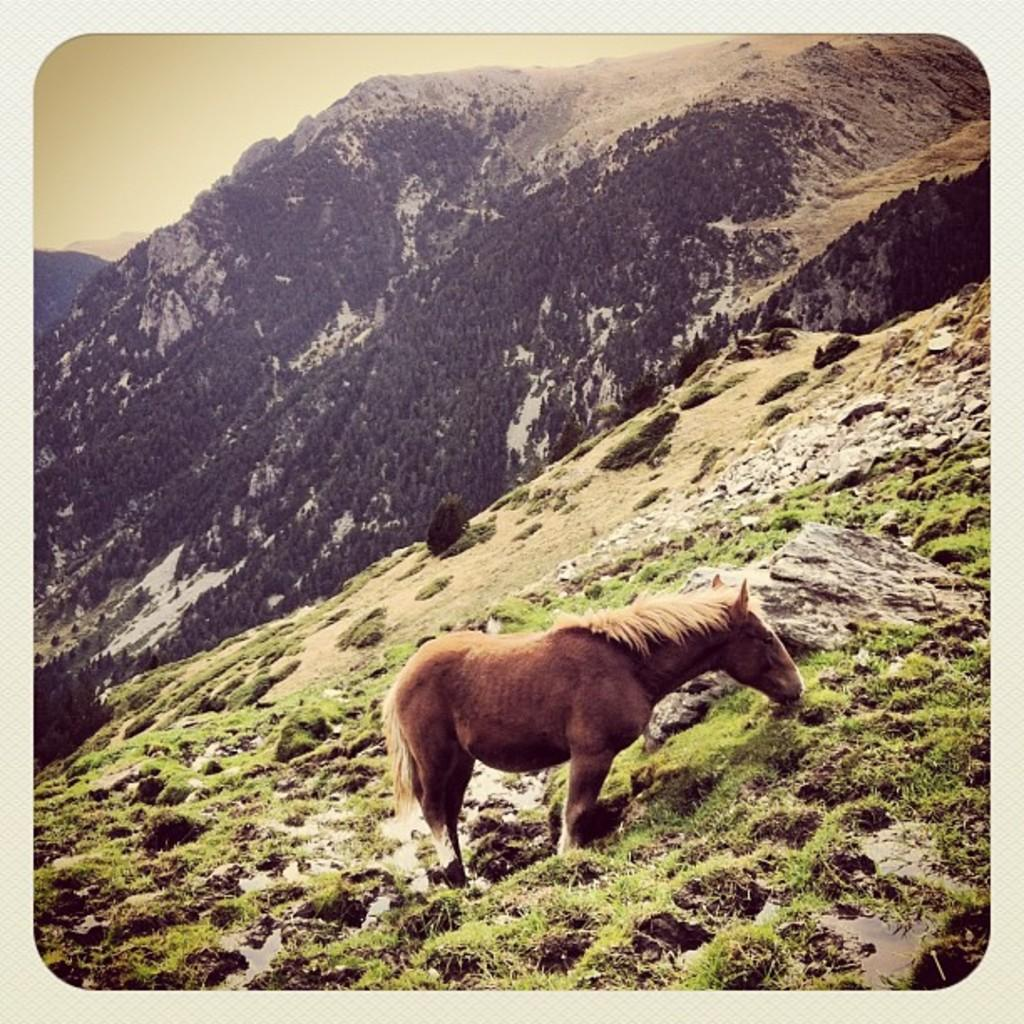What animal is present in the image? There is a horse in the image. What type of vegetation can be seen in the image? There is grass in the image. What other objects or features can be seen in the image? There are rocks in the image. What can be seen in the background of the image? There are hills, trees, and the sky visible in the background of the image. What tendency does the marble have in the image? There is no marble present in the image, so it is not possible to determine any tendencies. 